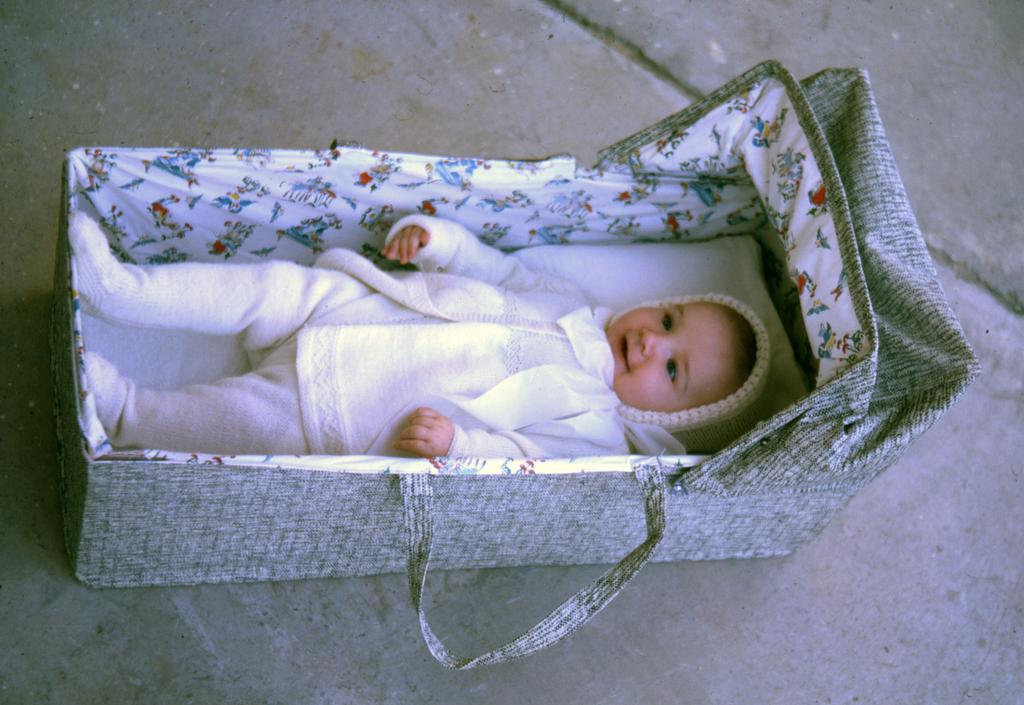Can you describe this image briefly? In this picture, it seems like a small baby in a basket in the foreground. 